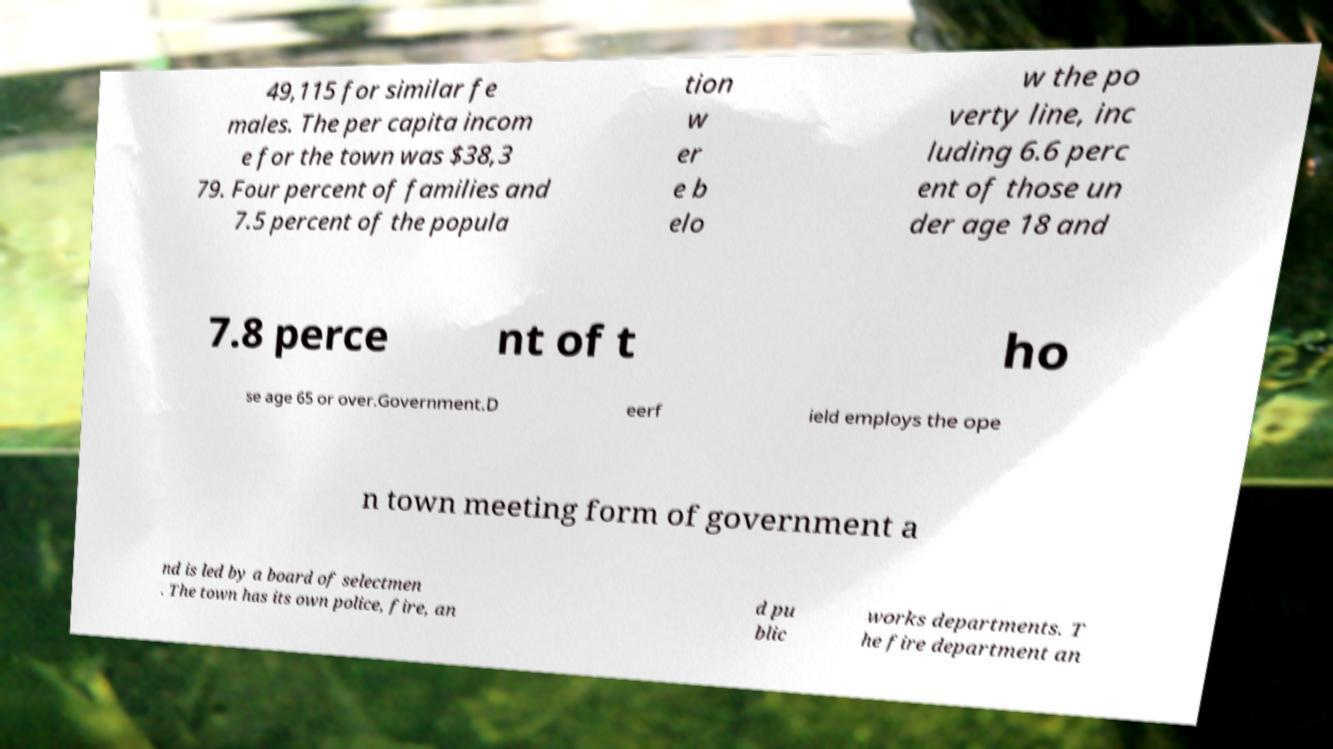I need the written content from this picture converted into text. Can you do that? 49,115 for similar fe males. The per capita incom e for the town was $38,3 79. Four percent of families and 7.5 percent of the popula tion w er e b elo w the po verty line, inc luding 6.6 perc ent of those un der age 18 and 7.8 perce nt of t ho se age 65 or over.Government.D eerf ield employs the ope n town meeting form of government a nd is led by a board of selectmen . The town has its own police, fire, an d pu blic works departments. T he fire department an 